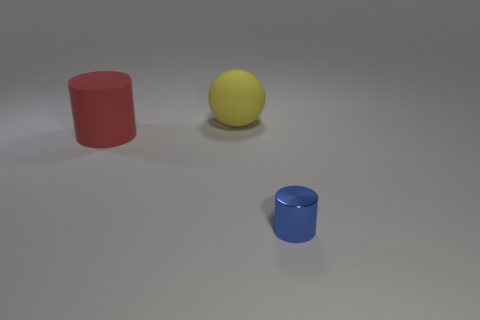What can you tell me about the texture of the objects? The objects in the image have a smooth and matte texture, with no reflections or glossiness discernible on their surfaces. Do the objects have any markings or distinct features? No, the objects are solid colored without any visible markings, patterns, or text. The red and blue objects are cylinders, and the yellow object is a sphere. 